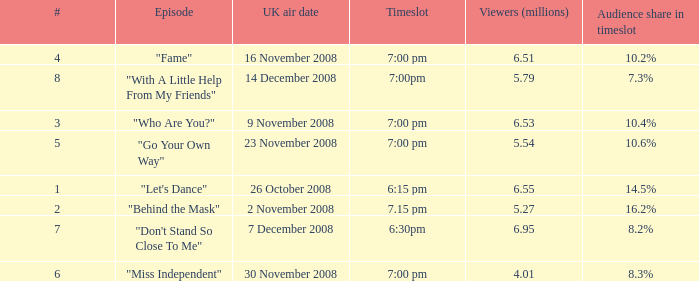Name the total number of timeslot for number 1 1.0. 